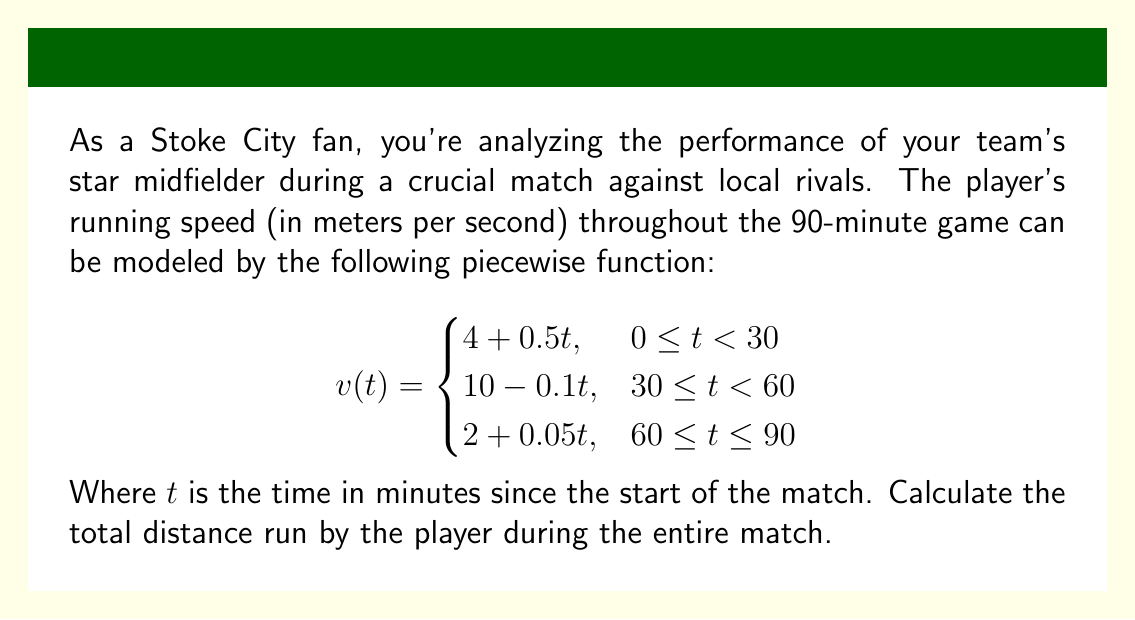Help me with this question. To find the total distance run by the player, we need to calculate the area under the velocity-time curve. This can be done by integrating the piecewise function over the entire 90-minute interval.

1. Split the integral into three parts, one for each piece of the function:

   $$\text{Total Distance} = \int_0^{30} (4 + 0.5t) dt + \int_{30}^{60} (10 - 0.1t) dt + \int_{60}^{90} (2 + 0.05t) dt$$

2. Evaluate each integral:

   First interval (0-30 minutes):
   $$\int_0^{30} (4 + 0.5t) dt = [4t + 0.25t^2]_0^{30} = (120 + 225) - (0 + 0) = 345$$

   Second interval (30-60 minutes):
   $$\int_{30}^{60} (10 - 0.1t) dt = [10t - 0.05t^2]_{30}^{60} = (600 - 180) - (300 - 45) = 165$$

   Third interval (60-90 minutes):
   $$\int_{60}^{90} (2 + 0.05t) dt = [2t + 0.025t^2]_{60}^{90} = (180 + 202.5) - (120 + 90) = 172.5$$

3. Sum up the distances from each interval:

   $$\text{Total Distance} = 345 + 165 + 172.5 = 682.5 \text{ meters}$$

Therefore, the player ran a total distance of 682.5 meters during the 90-minute match.
Answer: 682.5 meters 